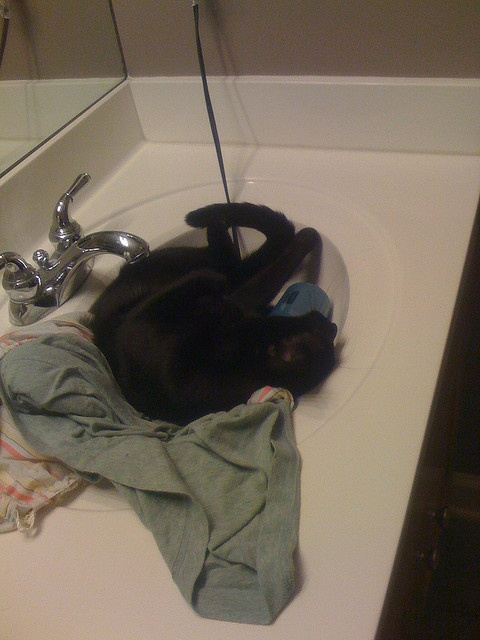Describe the objects in this image and their specific colors. I can see sink in maroon, black, tan, and gray tones, cat in maroon, black, and gray tones, and hair drier in maroon, black, purple, and gray tones in this image. 